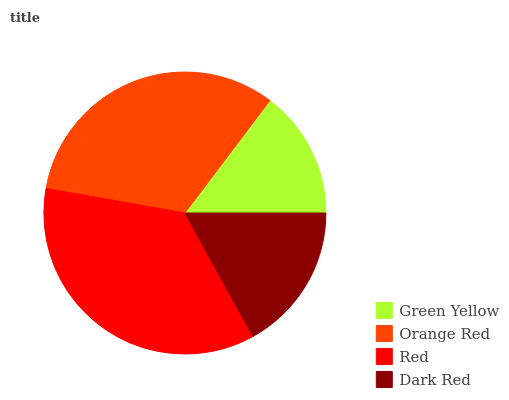Is Green Yellow the minimum?
Answer yes or no. Yes. Is Red the maximum?
Answer yes or no. Yes. Is Orange Red the minimum?
Answer yes or no. No. Is Orange Red the maximum?
Answer yes or no. No. Is Orange Red greater than Green Yellow?
Answer yes or no. Yes. Is Green Yellow less than Orange Red?
Answer yes or no. Yes. Is Green Yellow greater than Orange Red?
Answer yes or no. No. Is Orange Red less than Green Yellow?
Answer yes or no. No. Is Orange Red the high median?
Answer yes or no. Yes. Is Dark Red the low median?
Answer yes or no. Yes. Is Green Yellow the high median?
Answer yes or no. No. Is Green Yellow the low median?
Answer yes or no. No. 